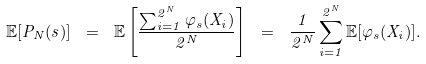<formula> <loc_0><loc_0><loc_500><loc_500>\mathbb { E } [ P _ { N } ( s ) ] \ = \ \mathbb { E } \left [ \frac { \sum _ { i = 1 } ^ { 2 ^ { N } } \varphi _ { s } ( X _ { i } ) } { 2 ^ { N } } \right ] \ = \ \frac { 1 } { 2 ^ { N } } \sum _ { i = 1 } ^ { 2 ^ { N } } \mathbb { E } [ \varphi _ { s } ( X _ { i } ) ] .</formula> 